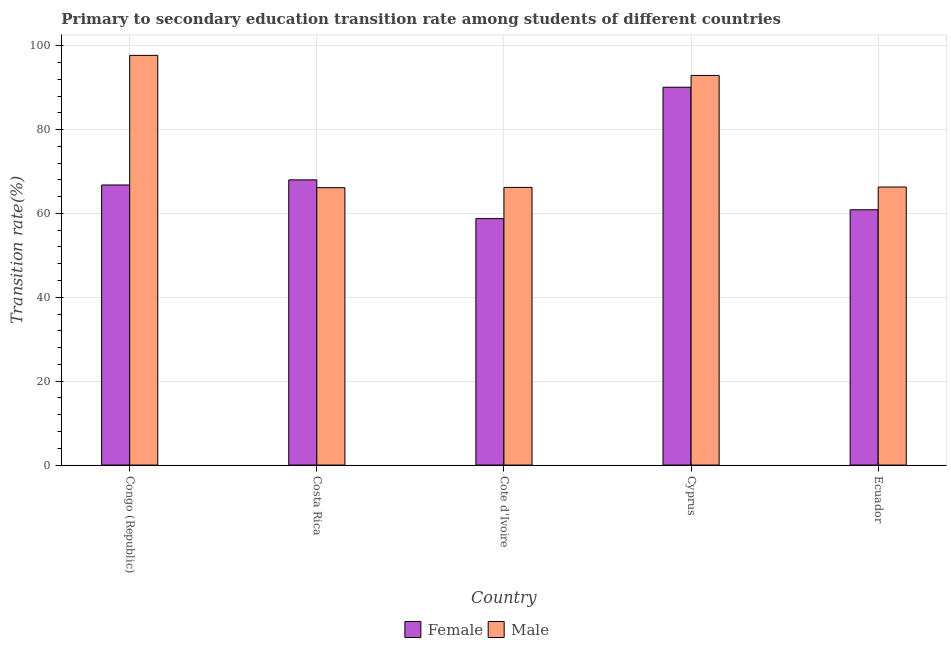Are the number of bars on each tick of the X-axis equal?
Ensure brevity in your answer.  Yes. How many bars are there on the 5th tick from the left?
Keep it short and to the point. 2. How many bars are there on the 5th tick from the right?
Offer a very short reply. 2. What is the label of the 4th group of bars from the left?
Your answer should be compact. Cyprus. What is the transition rate among female students in Ecuador?
Ensure brevity in your answer.  60.88. Across all countries, what is the maximum transition rate among female students?
Provide a short and direct response. 90.09. Across all countries, what is the minimum transition rate among male students?
Provide a short and direct response. 66.14. In which country was the transition rate among male students maximum?
Give a very brief answer. Congo (Republic). In which country was the transition rate among female students minimum?
Offer a very short reply. Cote d'Ivoire. What is the total transition rate among female students in the graph?
Your answer should be compact. 344.52. What is the difference between the transition rate among male students in Cote d'Ivoire and that in Ecuador?
Provide a short and direct response. -0.09. What is the difference between the transition rate among female students in Congo (Republic) and the transition rate among male students in Cyprus?
Provide a short and direct response. -26.12. What is the average transition rate among male students per country?
Your answer should be compact. 77.85. What is the difference between the transition rate among male students and transition rate among female students in Congo (Republic)?
Make the answer very short. 30.9. In how many countries, is the transition rate among female students greater than 96 %?
Ensure brevity in your answer.  0. What is the ratio of the transition rate among female students in Congo (Republic) to that in Ecuador?
Keep it short and to the point. 1.1. Is the difference between the transition rate among female students in Cote d'Ivoire and Cyprus greater than the difference between the transition rate among male students in Cote d'Ivoire and Cyprus?
Keep it short and to the point. No. What is the difference between the highest and the second highest transition rate among female students?
Your answer should be very brief. 22.09. What is the difference between the highest and the lowest transition rate among male students?
Give a very brief answer. 31.55. In how many countries, is the transition rate among male students greater than the average transition rate among male students taken over all countries?
Your answer should be very brief. 2. Are all the bars in the graph horizontal?
Keep it short and to the point. No. What is the difference between two consecutive major ticks on the Y-axis?
Provide a short and direct response. 20. How many legend labels are there?
Offer a terse response. 2. What is the title of the graph?
Ensure brevity in your answer.  Primary to secondary education transition rate among students of different countries. Does "National Visitors" appear as one of the legend labels in the graph?
Give a very brief answer. No. What is the label or title of the X-axis?
Make the answer very short. Country. What is the label or title of the Y-axis?
Provide a short and direct response. Transition rate(%). What is the Transition rate(%) of Female in Congo (Republic)?
Offer a very short reply. 66.79. What is the Transition rate(%) in Male in Congo (Republic)?
Provide a succinct answer. 97.69. What is the Transition rate(%) in Female in Costa Rica?
Your answer should be very brief. 68. What is the Transition rate(%) in Male in Costa Rica?
Your answer should be very brief. 66.14. What is the Transition rate(%) of Female in Cote d'Ivoire?
Ensure brevity in your answer.  58.77. What is the Transition rate(%) in Male in Cote d'Ivoire?
Keep it short and to the point. 66.21. What is the Transition rate(%) in Female in Cyprus?
Provide a succinct answer. 90.09. What is the Transition rate(%) in Male in Cyprus?
Your answer should be very brief. 92.9. What is the Transition rate(%) of Female in Ecuador?
Make the answer very short. 60.88. What is the Transition rate(%) of Male in Ecuador?
Your answer should be compact. 66.3. Across all countries, what is the maximum Transition rate(%) of Female?
Provide a short and direct response. 90.09. Across all countries, what is the maximum Transition rate(%) in Male?
Ensure brevity in your answer.  97.69. Across all countries, what is the minimum Transition rate(%) of Female?
Ensure brevity in your answer.  58.77. Across all countries, what is the minimum Transition rate(%) in Male?
Your answer should be compact. 66.14. What is the total Transition rate(%) of Female in the graph?
Keep it short and to the point. 344.52. What is the total Transition rate(%) of Male in the graph?
Keep it short and to the point. 389.24. What is the difference between the Transition rate(%) of Female in Congo (Republic) and that in Costa Rica?
Make the answer very short. -1.21. What is the difference between the Transition rate(%) in Male in Congo (Republic) and that in Costa Rica?
Provide a short and direct response. 31.55. What is the difference between the Transition rate(%) in Female in Congo (Republic) and that in Cote d'Ivoire?
Offer a terse response. 8.02. What is the difference between the Transition rate(%) of Male in Congo (Republic) and that in Cote d'Ivoire?
Offer a terse response. 31.48. What is the difference between the Transition rate(%) in Female in Congo (Republic) and that in Cyprus?
Your response must be concise. -23.3. What is the difference between the Transition rate(%) of Male in Congo (Republic) and that in Cyprus?
Your answer should be very brief. 4.79. What is the difference between the Transition rate(%) of Female in Congo (Republic) and that in Ecuador?
Offer a terse response. 5.91. What is the difference between the Transition rate(%) in Male in Congo (Republic) and that in Ecuador?
Your answer should be very brief. 31.39. What is the difference between the Transition rate(%) in Female in Costa Rica and that in Cote d'Ivoire?
Your answer should be very brief. 9.23. What is the difference between the Transition rate(%) in Male in Costa Rica and that in Cote d'Ivoire?
Make the answer very short. -0.07. What is the difference between the Transition rate(%) of Female in Costa Rica and that in Cyprus?
Your answer should be very brief. -22.09. What is the difference between the Transition rate(%) of Male in Costa Rica and that in Cyprus?
Your answer should be compact. -26.76. What is the difference between the Transition rate(%) of Female in Costa Rica and that in Ecuador?
Keep it short and to the point. 7.12. What is the difference between the Transition rate(%) in Male in Costa Rica and that in Ecuador?
Your answer should be very brief. -0.15. What is the difference between the Transition rate(%) of Female in Cote d'Ivoire and that in Cyprus?
Your answer should be very brief. -31.32. What is the difference between the Transition rate(%) of Male in Cote d'Ivoire and that in Cyprus?
Your response must be concise. -26.7. What is the difference between the Transition rate(%) of Female in Cote d'Ivoire and that in Ecuador?
Your response must be concise. -2.11. What is the difference between the Transition rate(%) of Male in Cote d'Ivoire and that in Ecuador?
Your response must be concise. -0.09. What is the difference between the Transition rate(%) of Female in Cyprus and that in Ecuador?
Your answer should be compact. 29.21. What is the difference between the Transition rate(%) in Male in Cyprus and that in Ecuador?
Offer a very short reply. 26.61. What is the difference between the Transition rate(%) in Female in Congo (Republic) and the Transition rate(%) in Male in Costa Rica?
Your answer should be very brief. 0.65. What is the difference between the Transition rate(%) in Female in Congo (Republic) and the Transition rate(%) in Male in Cote d'Ivoire?
Your answer should be very brief. 0.58. What is the difference between the Transition rate(%) of Female in Congo (Republic) and the Transition rate(%) of Male in Cyprus?
Ensure brevity in your answer.  -26.12. What is the difference between the Transition rate(%) in Female in Congo (Republic) and the Transition rate(%) in Male in Ecuador?
Offer a very short reply. 0.49. What is the difference between the Transition rate(%) in Female in Costa Rica and the Transition rate(%) in Male in Cote d'Ivoire?
Make the answer very short. 1.79. What is the difference between the Transition rate(%) in Female in Costa Rica and the Transition rate(%) in Male in Cyprus?
Give a very brief answer. -24.9. What is the difference between the Transition rate(%) in Female in Costa Rica and the Transition rate(%) in Male in Ecuador?
Your answer should be compact. 1.7. What is the difference between the Transition rate(%) in Female in Cote d'Ivoire and the Transition rate(%) in Male in Cyprus?
Give a very brief answer. -34.14. What is the difference between the Transition rate(%) of Female in Cote d'Ivoire and the Transition rate(%) of Male in Ecuador?
Make the answer very short. -7.53. What is the difference between the Transition rate(%) in Female in Cyprus and the Transition rate(%) in Male in Ecuador?
Provide a short and direct response. 23.79. What is the average Transition rate(%) of Female per country?
Ensure brevity in your answer.  68.9. What is the average Transition rate(%) of Male per country?
Keep it short and to the point. 77.85. What is the difference between the Transition rate(%) in Female and Transition rate(%) in Male in Congo (Republic)?
Provide a succinct answer. -30.9. What is the difference between the Transition rate(%) of Female and Transition rate(%) of Male in Costa Rica?
Make the answer very short. 1.86. What is the difference between the Transition rate(%) in Female and Transition rate(%) in Male in Cote d'Ivoire?
Give a very brief answer. -7.44. What is the difference between the Transition rate(%) in Female and Transition rate(%) in Male in Cyprus?
Keep it short and to the point. -2.82. What is the difference between the Transition rate(%) of Female and Transition rate(%) of Male in Ecuador?
Provide a short and direct response. -5.42. What is the ratio of the Transition rate(%) in Female in Congo (Republic) to that in Costa Rica?
Your response must be concise. 0.98. What is the ratio of the Transition rate(%) of Male in Congo (Republic) to that in Costa Rica?
Your answer should be compact. 1.48. What is the ratio of the Transition rate(%) of Female in Congo (Republic) to that in Cote d'Ivoire?
Offer a very short reply. 1.14. What is the ratio of the Transition rate(%) in Male in Congo (Republic) to that in Cote d'Ivoire?
Make the answer very short. 1.48. What is the ratio of the Transition rate(%) in Female in Congo (Republic) to that in Cyprus?
Provide a short and direct response. 0.74. What is the ratio of the Transition rate(%) in Male in Congo (Republic) to that in Cyprus?
Provide a succinct answer. 1.05. What is the ratio of the Transition rate(%) of Female in Congo (Republic) to that in Ecuador?
Provide a succinct answer. 1.1. What is the ratio of the Transition rate(%) of Male in Congo (Republic) to that in Ecuador?
Give a very brief answer. 1.47. What is the ratio of the Transition rate(%) in Female in Costa Rica to that in Cote d'Ivoire?
Keep it short and to the point. 1.16. What is the ratio of the Transition rate(%) in Male in Costa Rica to that in Cote d'Ivoire?
Give a very brief answer. 1. What is the ratio of the Transition rate(%) in Female in Costa Rica to that in Cyprus?
Provide a succinct answer. 0.75. What is the ratio of the Transition rate(%) in Male in Costa Rica to that in Cyprus?
Your answer should be very brief. 0.71. What is the ratio of the Transition rate(%) of Female in Costa Rica to that in Ecuador?
Offer a terse response. 1.12. What is the ratio of the Transition rate(%) of Female in Cote d'Ivoire to that in Cyprus?
Provide a succinct answer. 0.65. What is the ratio of the Transition rate(%) of Male in Cote d'Ivoire to that in Cyprus?
Ensure brevity in your answer.  0.71. What is the ratio of the Transition rate(%) in Female in Cote d'Ivoire to that in Ecuador?
Offer a terse response. 0.97. What is the ratio of the Transition rate(%) of Male in Cote d'Ivoire to that in Ecuador?
Your response must be concise. 1. What is the ratio of the Transition rate(%) of Female in Cyprus to that in Ecuador?
Your response must be concise. 1.48. What is the ratio of the Transition rate(%) in Male in Cyprus to that in Ecuador?
Offer a terse response. 1.4. What is the difference between the highest and the second highest Transition rate(%) of Female?
Give a very brief answer. 22.09. What is the difference between the highest and the second highest Transition rate(%) of Male?
Keep it short and to the point. 4.79. What is the difference between the highest and the lowest Transition rate(%) in Female?
Offer a very short reply. 31.32. What is the difference between the highest and the lowest Transition rate(%) of Male?
Make the answer very short. 31.55. 